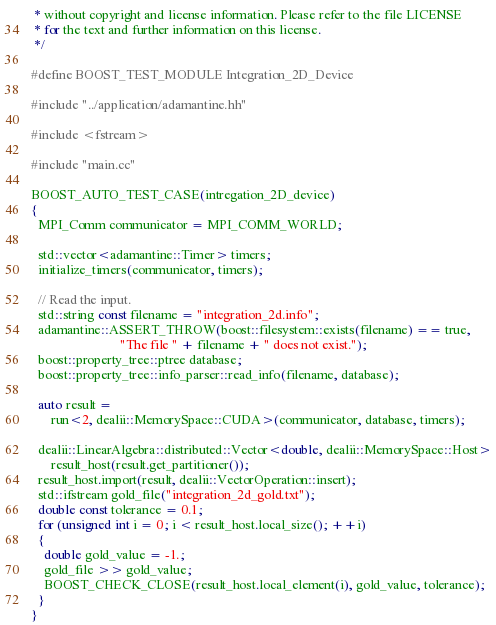Convert code to text. <code><loc_0><loc_0><loc_500><loc_500><_Cuda_> * without copyright and license information. Please refer to the file LICENSE
 * for the text and further information on this license.
 */

#define BOOST_TEST_MODULE Integration_2D_Device

#include "../application/adamantine.hh"

#include <fstream>

#include "main.cc"

BOOST_AUTO_TEST_CASE(intregation_2D_device)
{
  MPI_Comm communicator = MPI_COMM_WORLD;

  std::vector<adamantine::Timer> timers;
  initialize_timers(communicator, timers);

  // Read the input.
  std::string const filename = "integration_2d.info";
  adamantine::ASSERT_THROW(boost::filesystem::exists(filename) == true,
                           "The file " + filename + " does not exist.");
  boost::property_tree::ptree database;
  boost::property_tree::info_parser::read_info(filename, database);

  auto result =
      run<2, dealii::MemorySpace::CUDA>(communicator, database, timers);

  dealii::LinearAlgebra::distributed::Vector<double, dealii::MemorySpace::Host>
      result_host(result.get_partitioner());
  result_host.import(result, dealii::VectorOperation::insert);
  std::ifstream gold_file("integration_2d_gold.txt");
  double const tolerance = 0.1;
  for (unsigned int i = 0; i < result_host.local_size(); ++i)
  {
    double gold_value = -1.;
    gold_file >> gold_value;
    BOOST_CHECK_CLOSE(result_host.local_element(i), gold_value, tolerance);
  }
}
</code> 